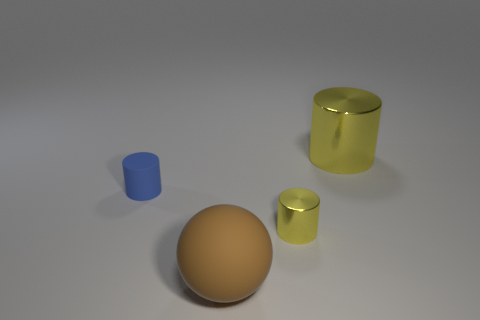Add 3 tiny shiny cylinders. How many objects exist? 7 Subtract all cylinders. How many objects are left? 1 Add 1 big matte blocks. How many big matte blocks exist? 1 Subtract 0 gray spheres. How many objects are left? 4 Subtract all tiny cylinders. Subtract all yellow objects. How many objects are left? 0 Add 3 small yellow objects. How many small yellow objects are left? 4 